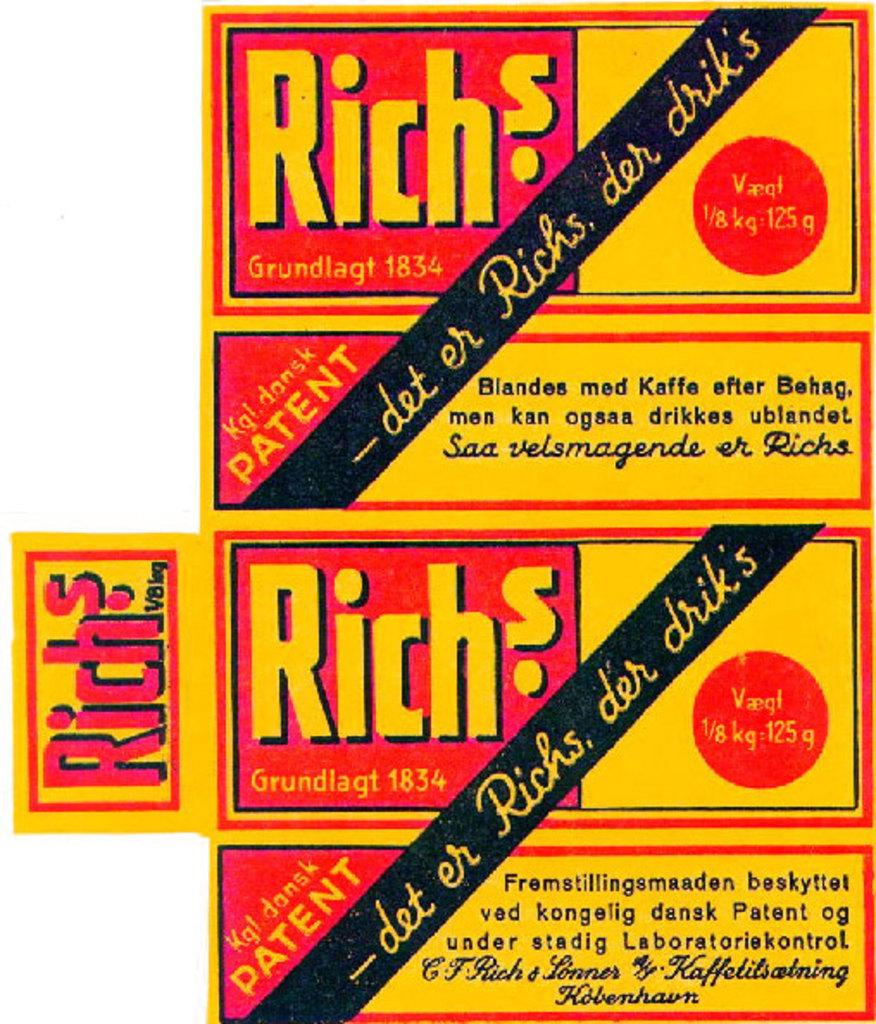<image>
Write a terse but informative summary of the picture. the yellow color design which shows the details of Richs brand drink with quantity of 125g in it. 